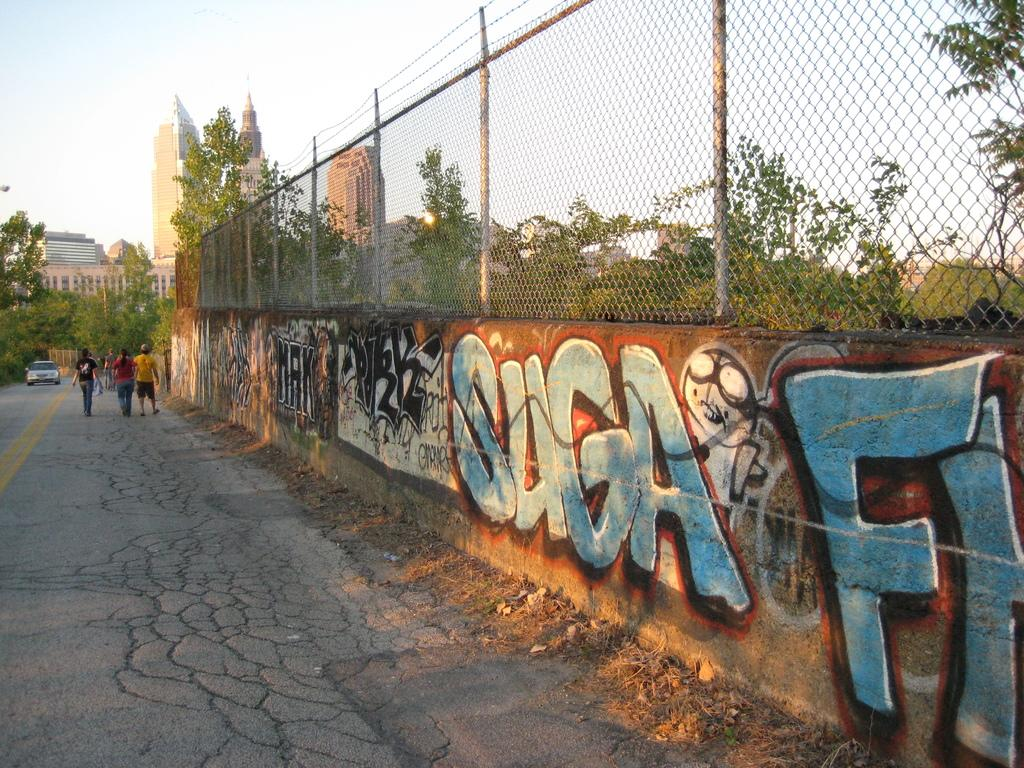What can be seen in the sky in the image? The sky is visible in the image. What type of structures are present in the image? There are skyscrapers and buildings in the image. What mode of transportation can be seen in the image? Motor vehicles are present in the image. Are there any people visible in the image? Yes, there are persons on the road in the image. What else can be seen on the walls in the image? Advertisements are visible on the walls in the image. What type of material is present in the image? There is mesh in the image. What type of natural elements are present in the image? Trees are present in the image. Can you tell me how many baseballs are being hit by the truck in the image? There is no truck or baseballs present in the image. What type of rail is visible in the image? There is no rail present in the image. 